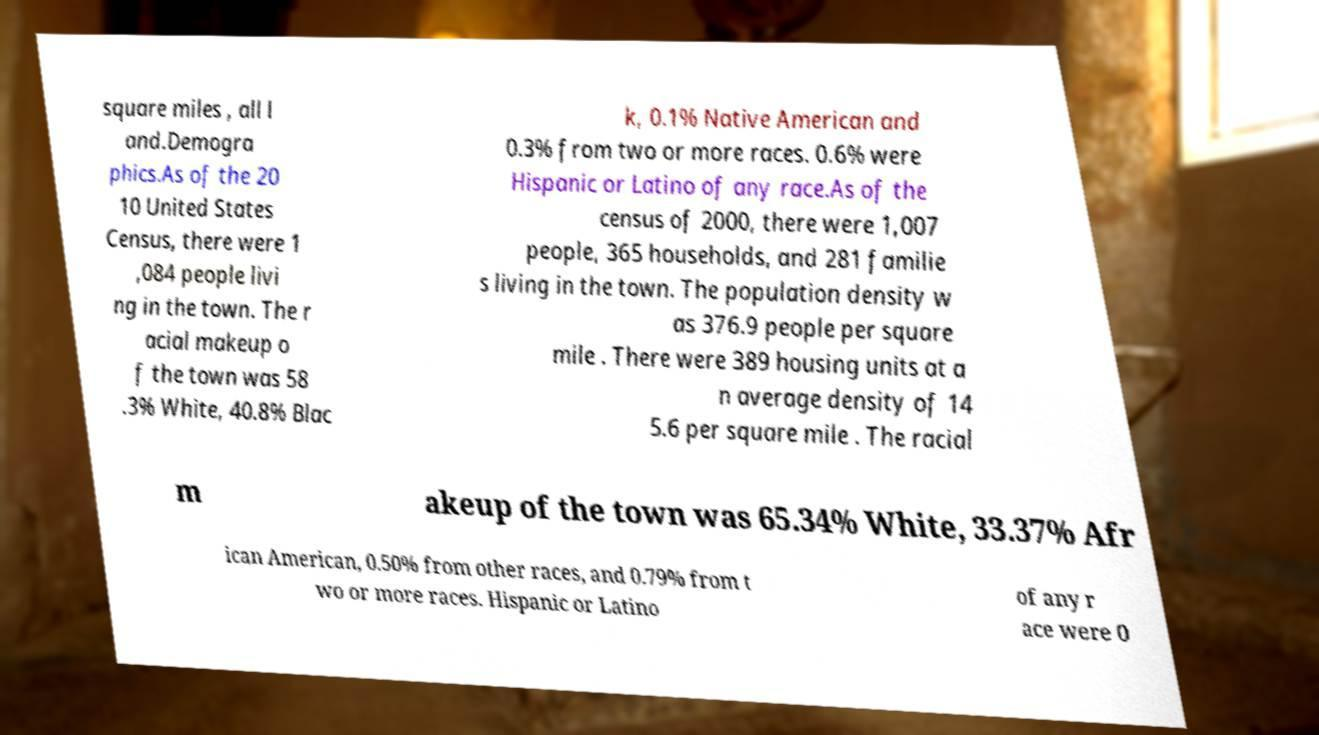For documentation purposes, I need the text within this image transcribed. Could you provide that? square miles , all l and.Demogra phics.As of the 20 10 United States Census, there were 1 ,084 people livi ng in the town. The r acial makeup o f the town was 58 .3% White, 40.8% Blac k, 0.1% Native American and 0.3% from two or more races. 0.6% were Hispanic or Latino of any race.As of the census of 2000, there were 1,007 people, 365 households, and 281 familie s living in the town. The population density w as 376.9 people per square mile . There were 389 housing units at a n average density of 14 5.6 per square mile . The racial m akeup of the town was 65.34% White, 33.37% Afr ican American, 0.50% from other races, and 0.79% from t wo or more races. Hispanic or Latino of any r ace were 0 